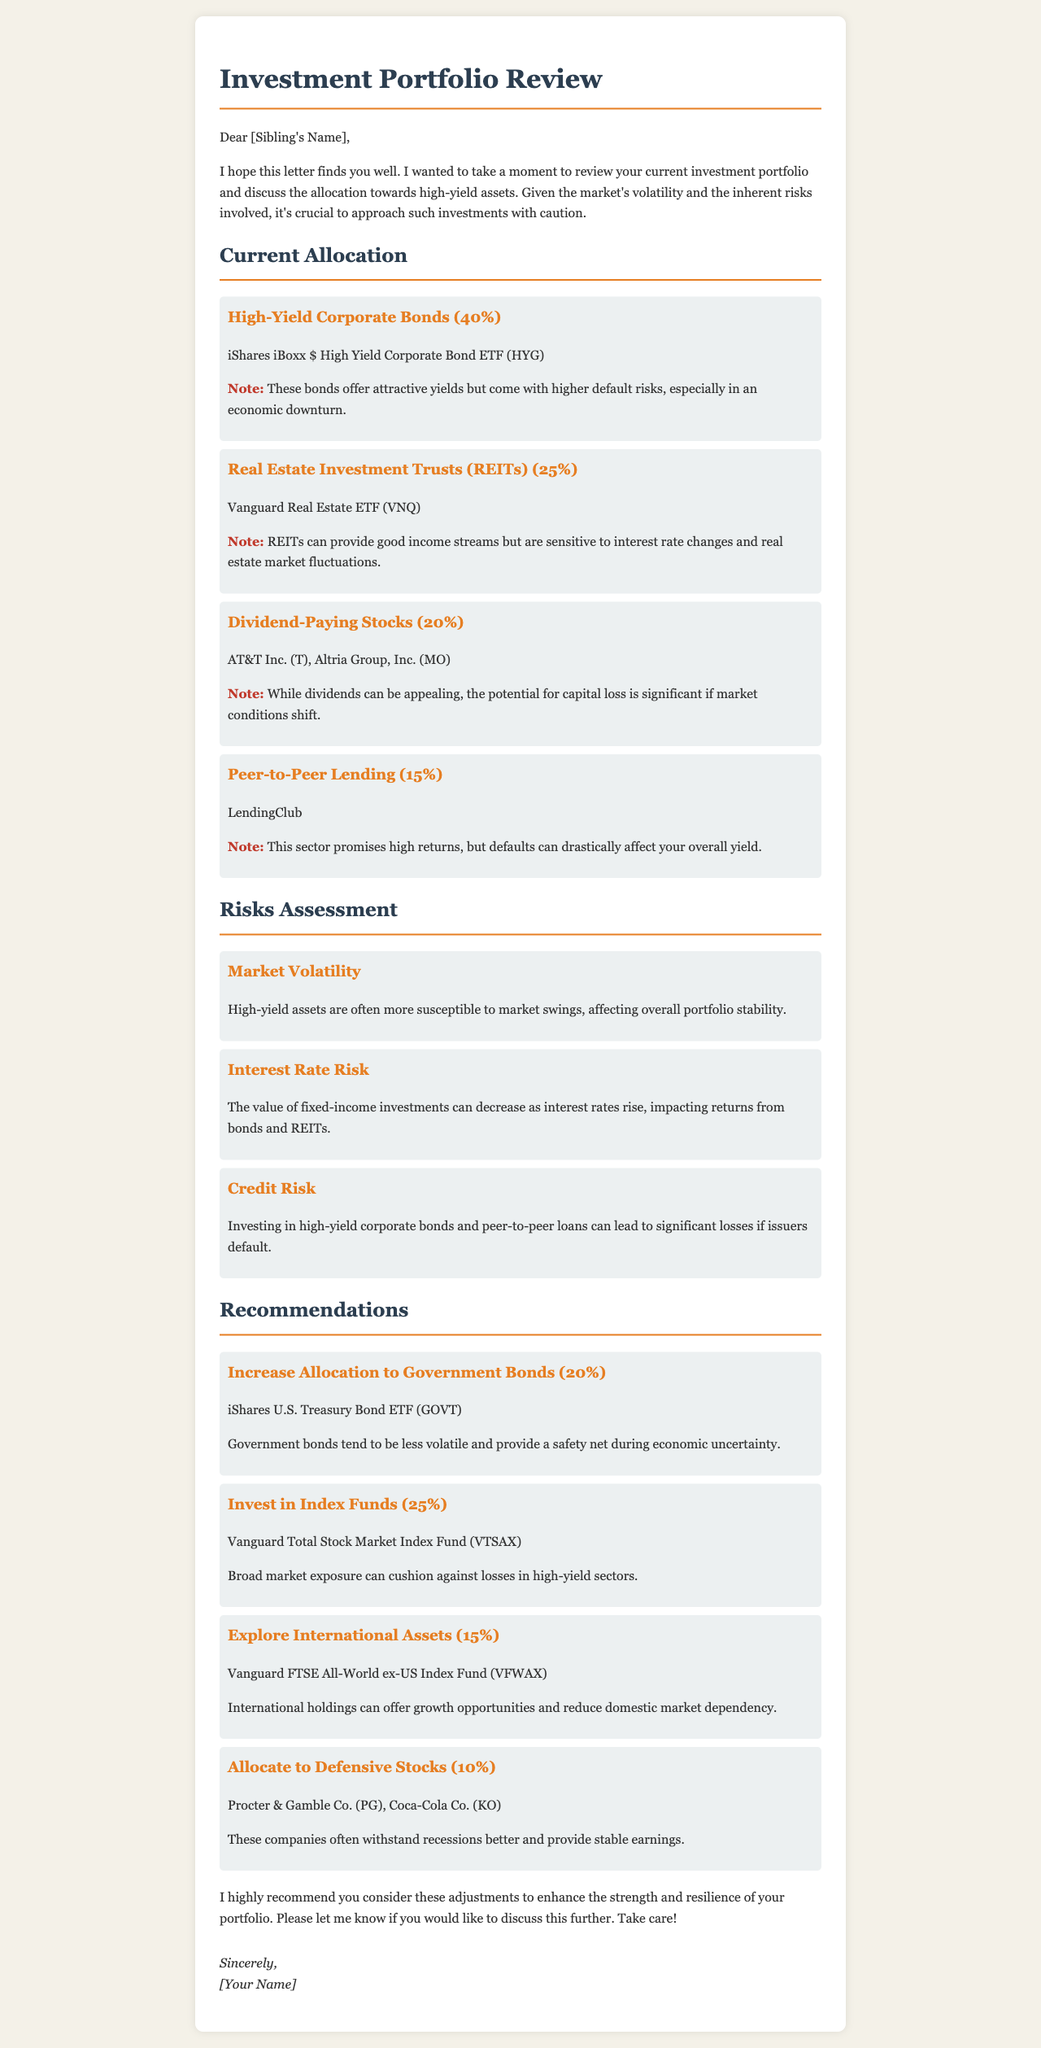What is the percentage allocation for High-Yield Corporate Bonds? The document states that High-Yield Corporate Bonds have a percentage allocation of 40%.
Answer: 40% What are the names of two companies listed under Dividend-Paying Stocks? The letter mentions AT&T Inc. and Altria Group, Inc. as Dividend-Paying Stocks.
Answer: AT&T Inc., Altria Group, Inc What is the recommended percentage allocation to Government Bonds? The document specifies an increase to Government Bonds at 20% as a recommendation.
Answer: 20% What risk is associated with Peer-to-Peer Lending? The document highlights that Peer-to-Peer Lending carries the risk of defaults, which can drastically affect overall yield.
Answer: Defaults What type of investment provides good income streams but is sensitive to interest rate changes? The letter states that Real Estate Investment Trusts (REITs) provide income streams but are sensitive to interest rate changes.
Answer: Real Estate Investment Trusts (REITs) What is the suggested allocation for Defensive Stocks? The recommendations section suggests allocating 10% to Defensive Stocks.
Answer: 10% What is the primary purpose of this investment portfolio review letter? The letter aims to assess the current allocation in high-yield assets and recommend diversification to manage risk.
Answer: Assess and recommend What does the warning note about High-Yield Corporate Bonds indicate? The warning note indicates that these bonds offer attractive yields but come with higher default risks, particularly in economic downturns.
Answer: Higher default risks What is the main concern with investing in high-yield assets mentioned in the risks assessment? The risks assessment discusses that high-yield assets are often more susceptible to market swings, affecting overall portfolio stability.
Answer: Market swings 